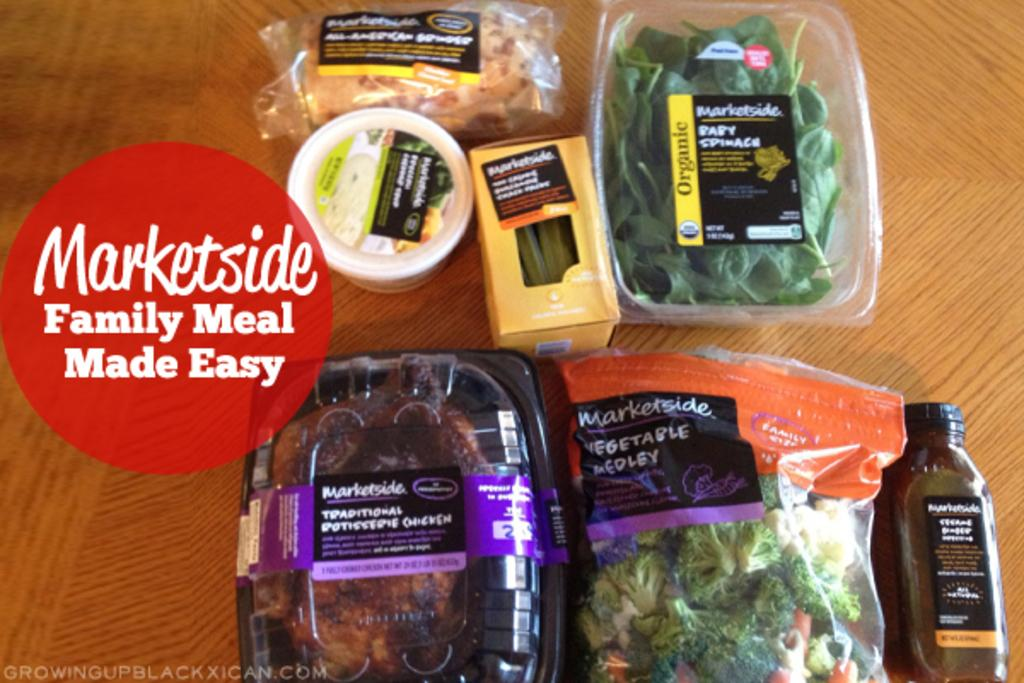Provide a one-sentence caption for the provided image. An advertisement for a market showing packages of various foods on a wooden table. 